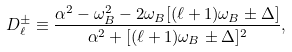Convert formula to latex. <formula><loc_0><loc_0><loc_500><loc_500>D _ { \ell } ^ { \pm } \equiv \frac { \alpha ^ { 2 } - \omega _ { B } ^ { 2 } - 2 \omega _ { B } [ ( \ell + 1 ) \omega _ { B } \pm \Delta ] } { \alpha ^ { 2 } + [ ( \ell + 1 ) \omega _ { B } \pm \Delta ] ^ { 2 } } ,</formula> 